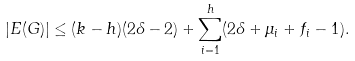<formula> <loc_0><loc_0><loc_500><loc_500>| E ( G ) | \leq ( k - h ) ( 2 \delta - 2 ) + \sum _ { i = 1 } ^ { h } ( 2 \delta + \mu _ { i } + f _ { i } - 1 ) .</formula> 